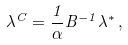<formula> <loc_0><loc_0><loc_500><loc_500>\lambda ^ { C } = \frac { 1 } { \alpha } B ^ { - 1 } \lambda ^ { * } \, ,</formula> 